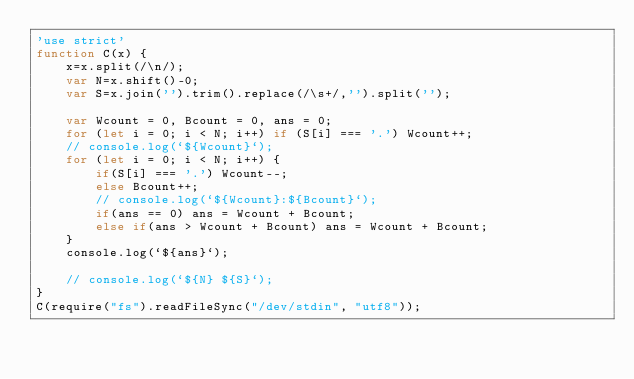<code> <loc_0><loc_0><loc_500><loc_500><_JavaScript_>'use strict'
function C(x) {
    x=x.split(/\n/);
    var N=x.shift()-0;
    var S=x.join('').trim().replace(/\s+/,'').split('');
    
    var Wcount = 0, Bcount = 0, ans = 0;
    for (let i = 0; i < N; i++) if (S[i] === '.') Wcount++;
    // console.log(`${Wcount}`);
    for (let i = 0; i < N; i++) {
        if(S[i] === '.') Wcount--; 
        else Bcount++;
        // console.log(`${Wcount}:${Bcount}`);
        if(ans == 0) ans = Wcount + Bcount;
        else if(ans > Wcount + Bcount) ans = Wcount + Bcount;
    }
    console.log(`${ans}`);
    
    // console.log(`${N} ${S}`);
}
C(require("fs").readFileSync("/dev/stdin", "utf8"));</code> 